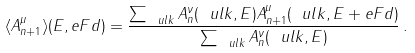Convert formula to latex. <formula><loc_0><loc_0><loc_500><loc_500>\langle A _ { n + 1 } ^ { \mu } \rangle ( E , e F d ) = \frac { \sum _ { \ u l { k } } A _ { n } ^ { \nu } ( \ u l { k } , E ) A _ { n + 1 } ^ { \mu } ( \ u l { k } , E + e F d ) } { \sum _ { \ u l { k } } A _ { n } ^ { \nu } ( \ u l { k } , E ) } \, .</formula> 